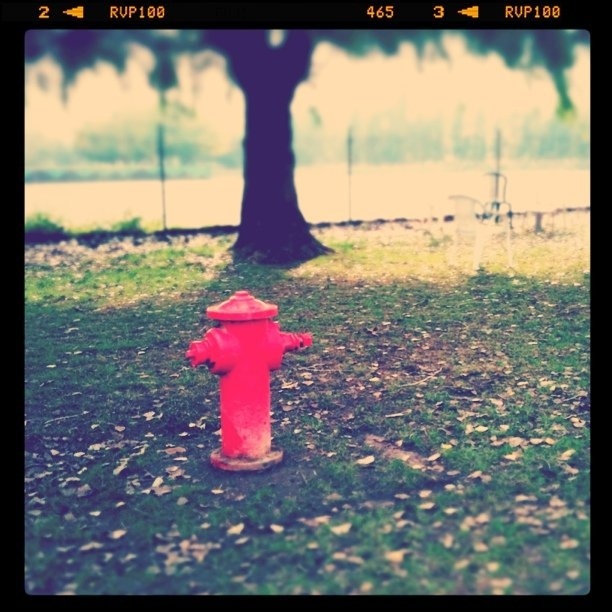Describe the objects in this image and their specific colors. I can see fire hydrant in black, salmon, and lightpink tones and chair in black, tan, darkgray, and gray tones in this image. 